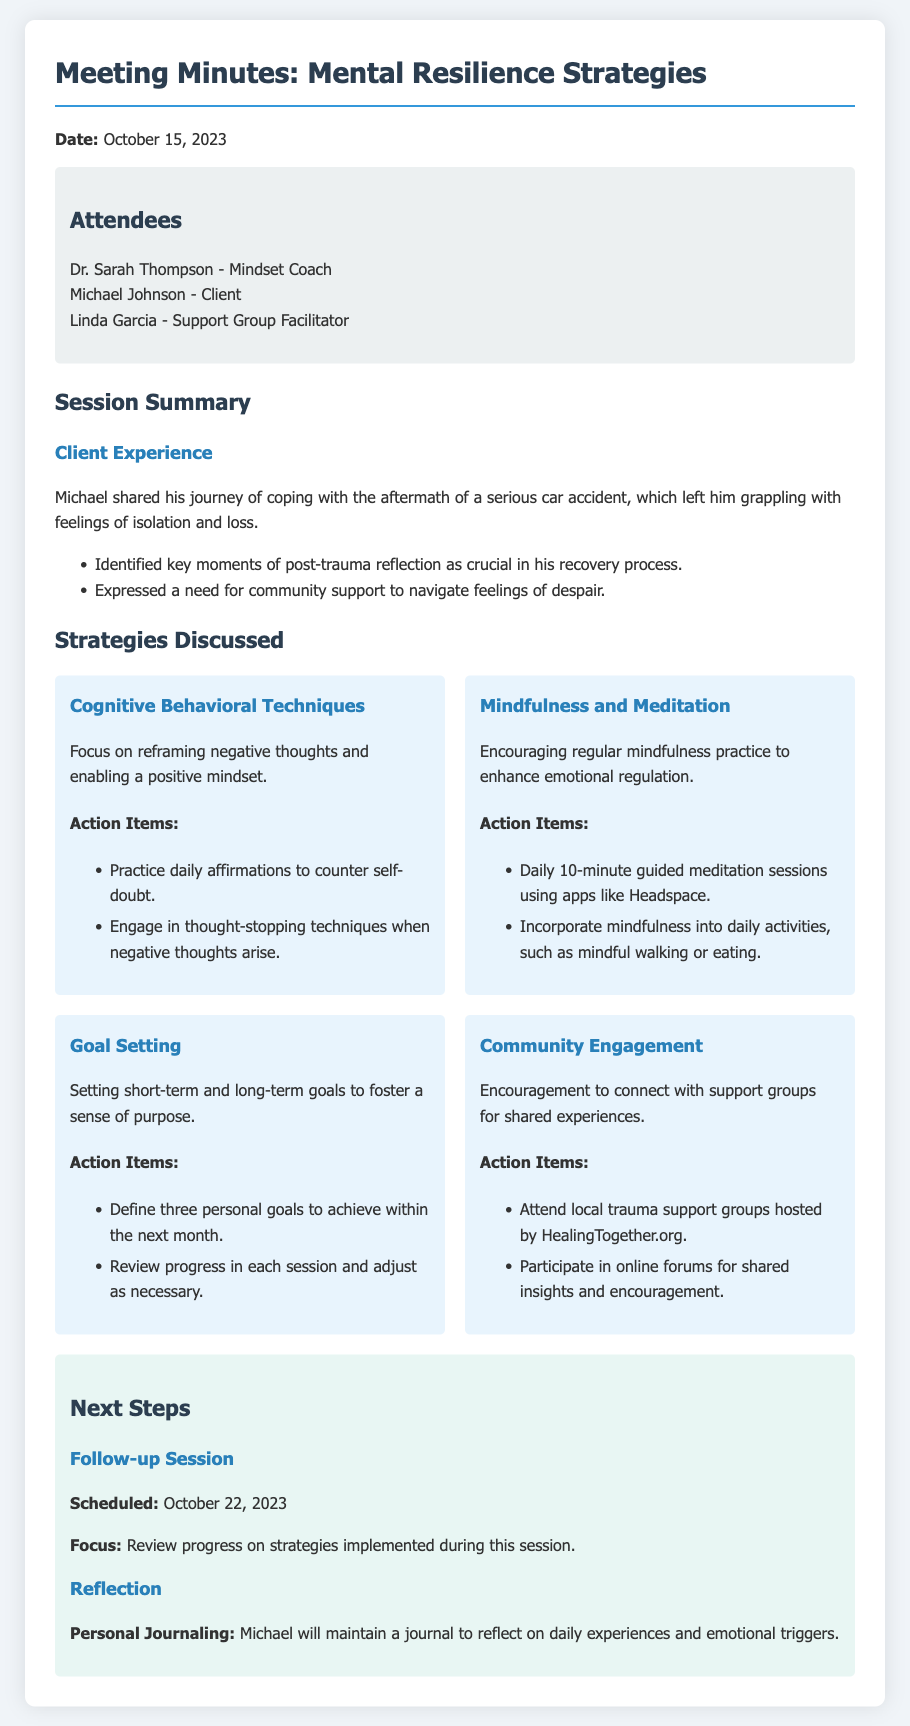What is the date of the meeting? The document states that the meeting took place on October 15, 2023.
Answer: October 15, 2023 Who was the client in the session? The minutes specify that Michael Johnson was the client attending the session.
Answer: Michael Johnson What is one key strategy discussed in the meeting? The document lists several strategies; one example is Cognitive Behavioral Techniques, which is highlighted in the strategies section.
Answer: Cognitive Behavioral Techniques How long are the daily meditation sessions suggested to be? The minutes indicate that daily guided meditation sessions should last 10 minutes.
Answer: 10 minutes What is the focus of the next session? The next session will focus on reviewing progress on strategies implemented during the current session.
Answer: Review progress on strategies implemented What action item relates to community engagement? The document includes an action item stating to attend local trauma support groups.
Answer: Attend local trauma support groups How many personal goals should Michael set for the next month? The action items specify that Michael should define three personal goals to achieve within the next month.
Answer: Three personal goals What is the personal journaling purpose for Michael? The document mentions that Michael will maintain a journal to reflect on daily experiences and emotional triggers.
Answer: Reflect on daily experiences and emotional triggers 